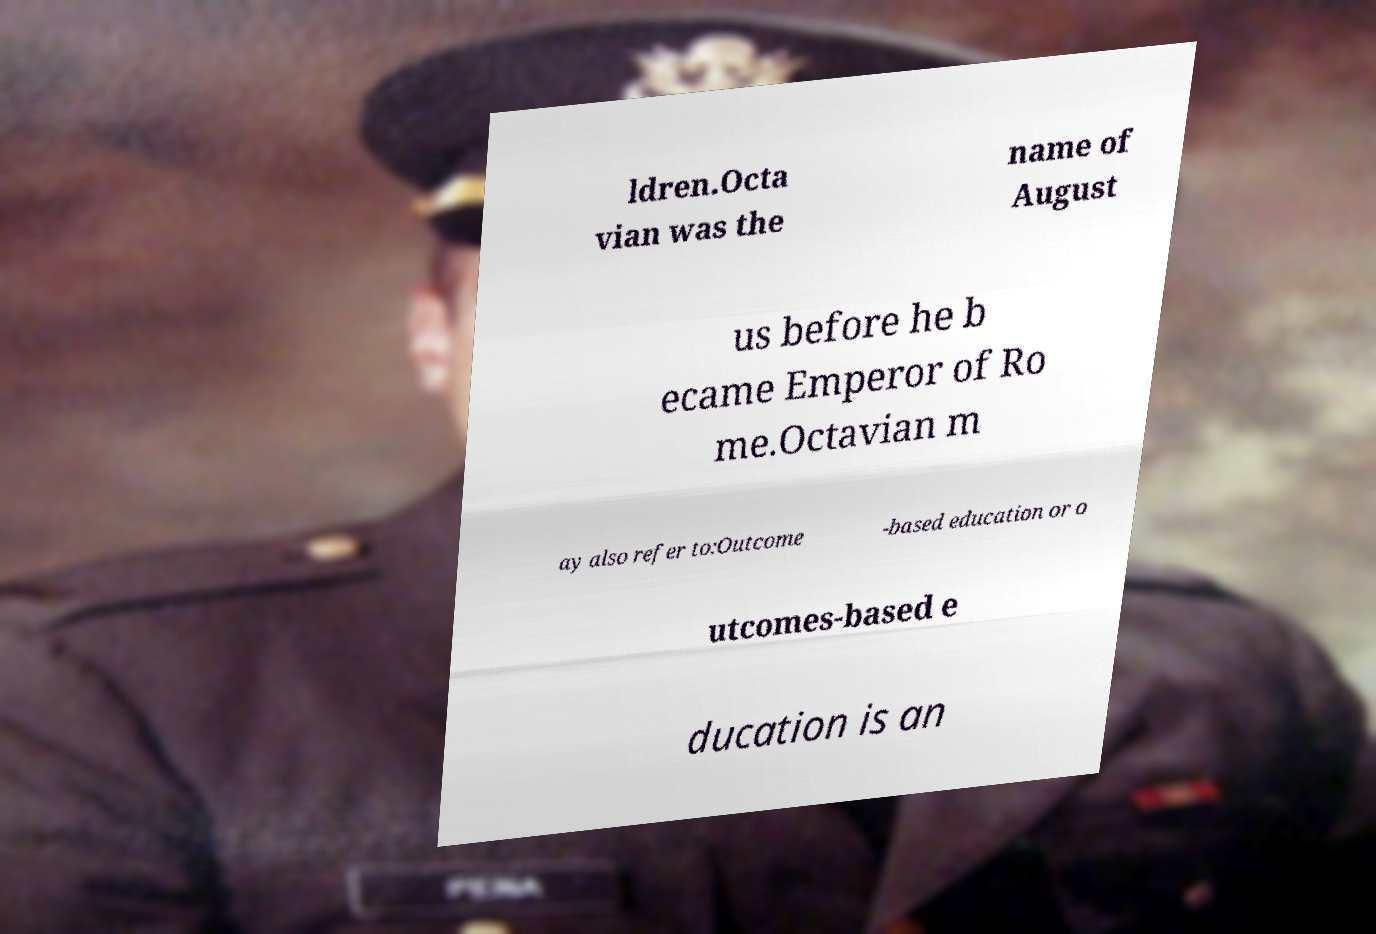Could you extract and type out the text from this image? ldren.Octa vian was the name of August us before he b ecame Emperor of Ro me.Octavian m ay also refer to:Outcome -based education or o utcomes-based e ducation is an 